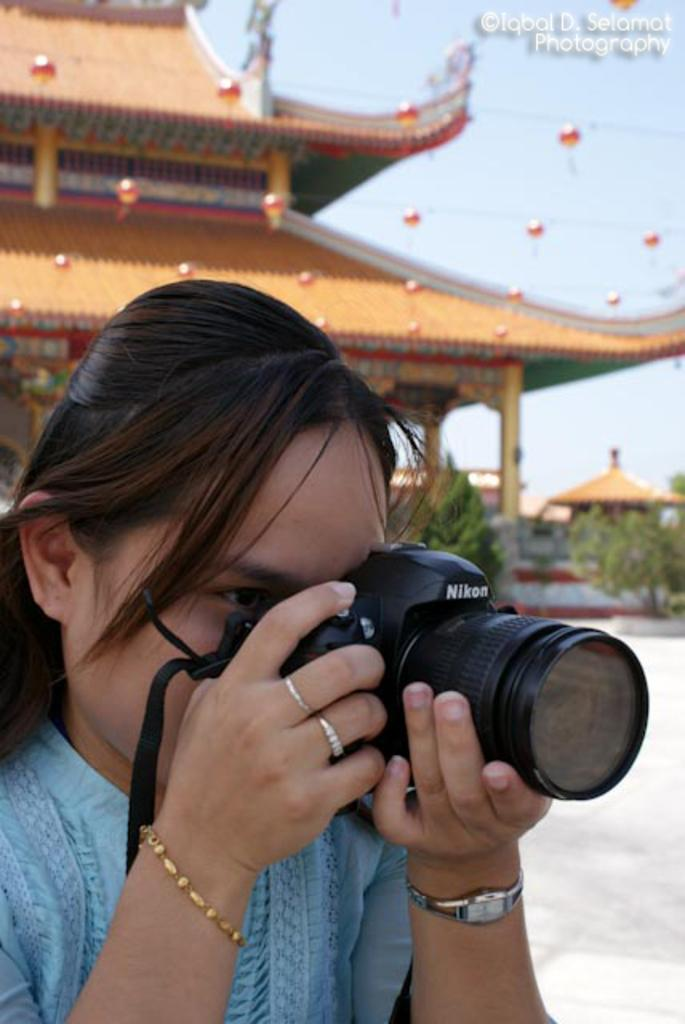Who is the main subject in the image? There is a woman in the image. What is the woman wearing? The woman is wearing a blue dress and a watch. Can you describe the woman's hairstyle? The woman has short hair. What is the woman holding in the image? The woman is holding a camera. What can be seen in the background of the image? There is a building, plants, and the sky visible in the background of the image. What type of riddle can be solved using the copper sink in the image? There is no copper sink present in the image, and therefore no riddle can be solved using it. 